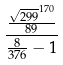Convert formula to latex. <formula><loc_0><loc_0><loc_500><loc_500>\frac { \frac { \sqrt { 2 9 9 } ^ { 1 7 0 } } { 8 9 } } { \frac { 8 } { 3 7 6 } - 1 }</formula> 